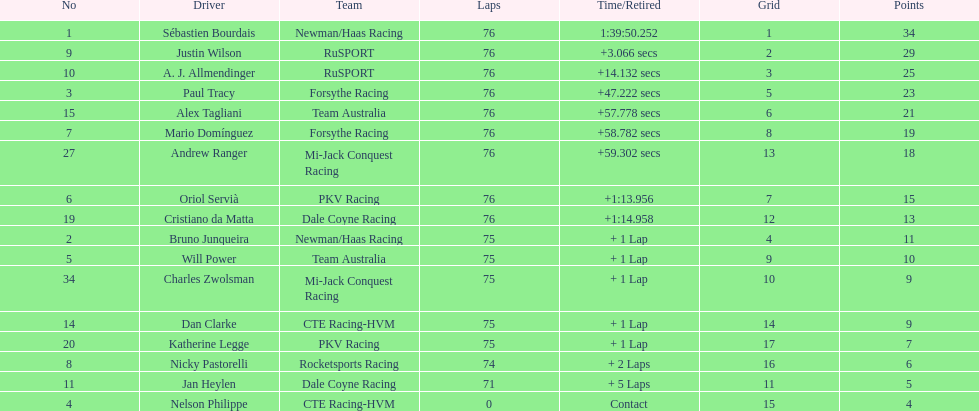Which driver earned the least amount of points. Nelson Philippe. 